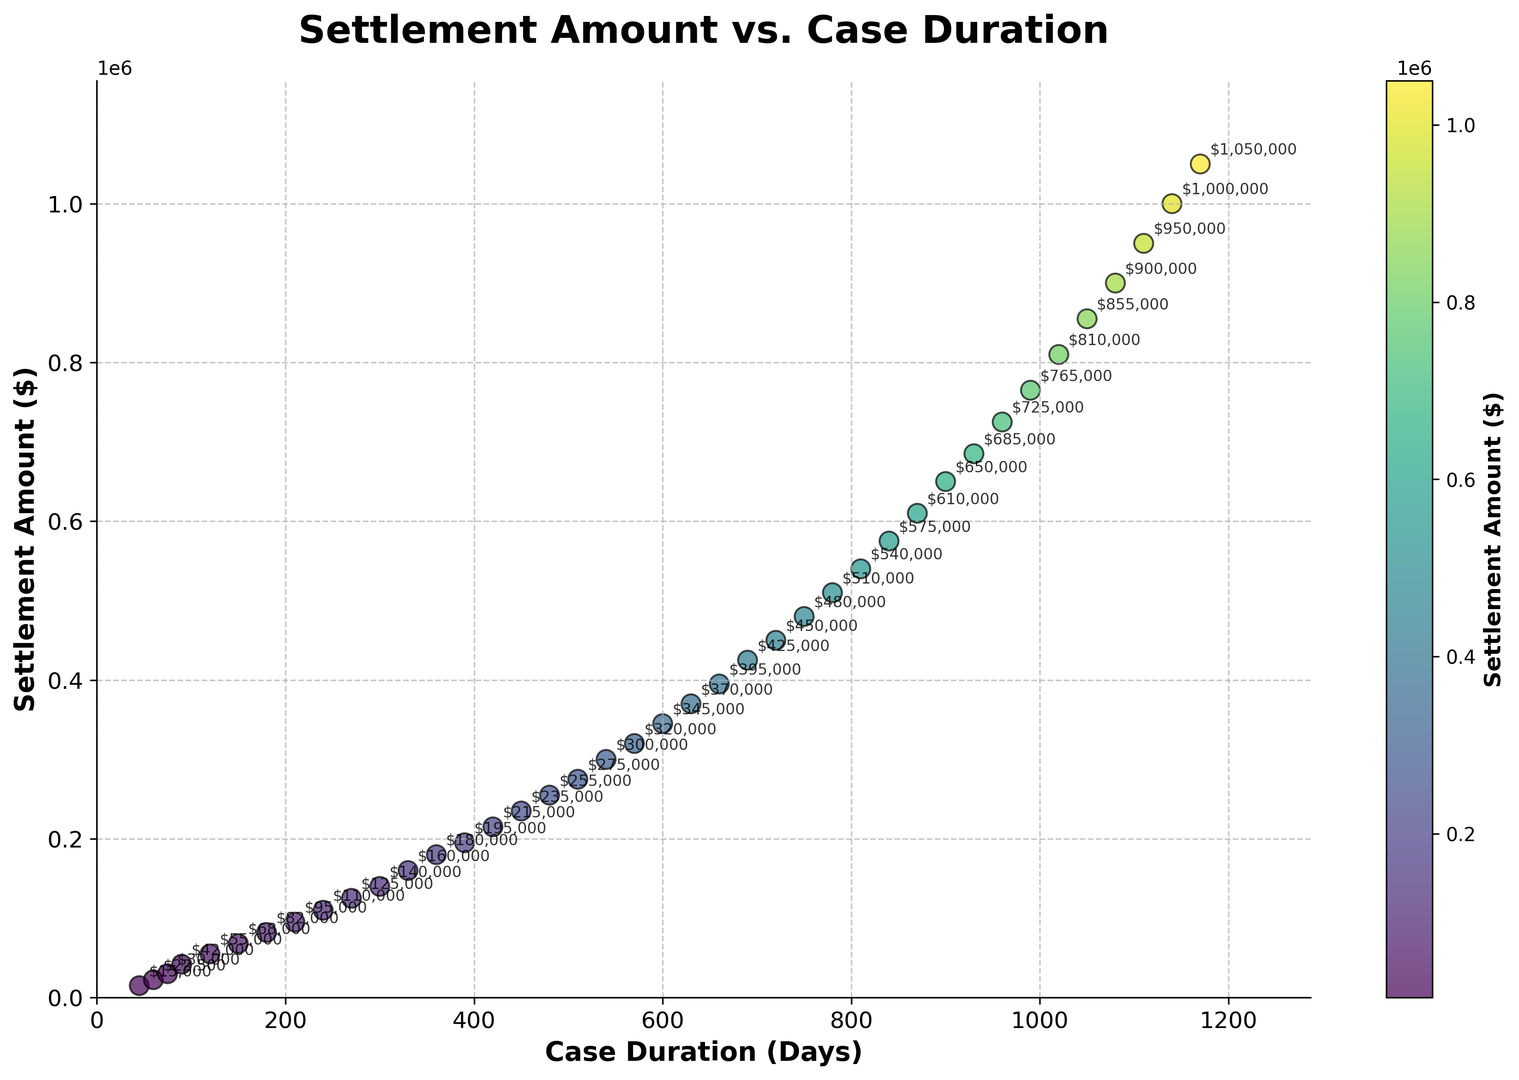What is the general trend between settlement amounts and case duration? By observing the scatter plot, one can see that as case duration increases, the settlement amount also increases, indicating a positive correlation.
Answer: Positive correlation What is the settlement amount for a case duration of 540 days? Locate the x-value (540 days) on the scatter plot and check the corresponding y-value (settlement amount). The settlement amount is shown as an annotation (300000).
Answer: $300,000 How does the settlement amount change between 600 and 720 days? Compare the settlement amounts at 600 days ($345,000) and 720 days ($450,000). The difference can be calculated by subtracting the former from the latter (450000 - 345000 = 105000).
Answer: Increase by $105,000 At what case duration does the settlement amount reach or exceed $500,000 for the first time? Locate the first data point where the settlement amount is $500,000 or more. This occurs at a case duration of 780 days.
Answer: 780 days What is the average settlement amount for cases lasting between 300 and 600 days? Identify the settlement amounts within the 300-600 day range ($140,000, $160,000, $180,000, $195,000, $215,000, $235,000, $255,000, $275,000, $300,000, $320,000, $345,000). Calculate the average: (140000 + 160000 + 180000 + 195000 + 215000 + 235000 + 255000 + 275000 + 300000 + 320000 + 345000) / 11 = 241818.18.
Answer: $241,818.18 How does the color of the data points change with increasing settlement amounts? The color of the data points transitions from lighter to darker shades of the colormap as the settlement amount increases, indicating higher values with darker shades.
Answer: Darker with higher amounts Which case duration has the lowest settlement amount, and what is it? Locate the data point with the minimum settlement amount, which corresponds to a case duration of 45 days and a settlement amount of $15,000.
Answer: 45 days, $15,000 What is the settlement amount for the longest case duration in the scatter plot? Find the data point with the maximum x-value (case duration). The longest duration is 1170 days, and the corresponding settlement amount is $1,050,000.
Answer: $1,050,000 Compare the settlement amounts for 330 days and 990 days. Which is higher? Check the settlement amounts for 330 days ($160,000) and 990 days ($765,000) and compare them. The settlement amount for 990 days is higher.
Answer: $765,000 is higher What is the median settlement amount for all the cases? Arrange all the settlement amounts in ascending order and identify the middle value. With 40 data points, the median is the average of the 20th and 21st values ($320,000 and $345,000): (320000 + 345000) / 2 = 332500.
Answer: $332,500 